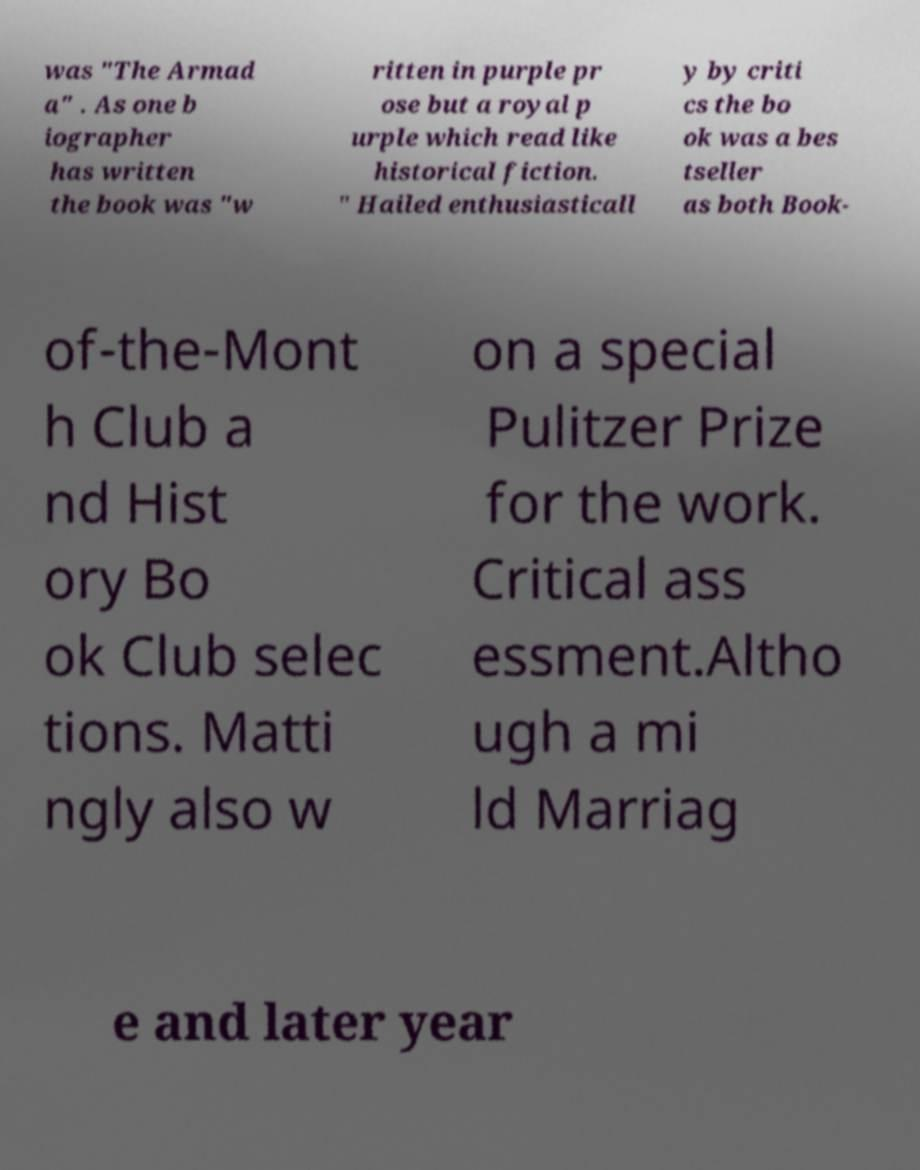What messages or text are displayed in this image? I need them in a readable, typed format. was "The Armad a" . As one b iographer has written the book was "w ritten in purple pr ose but a royal p urple which read like historical fiction. " Hailed enthusiasticall y by criti cs the bo ok was a bes tseller as both Book- of-the-Mont h Club a nd Hist ory Bo ok Club selec tions. Matti ngly also w on a special Pulitzer Prize for the work. Critical ass essment.Altho ugh a mi ld Marriag e and later year 